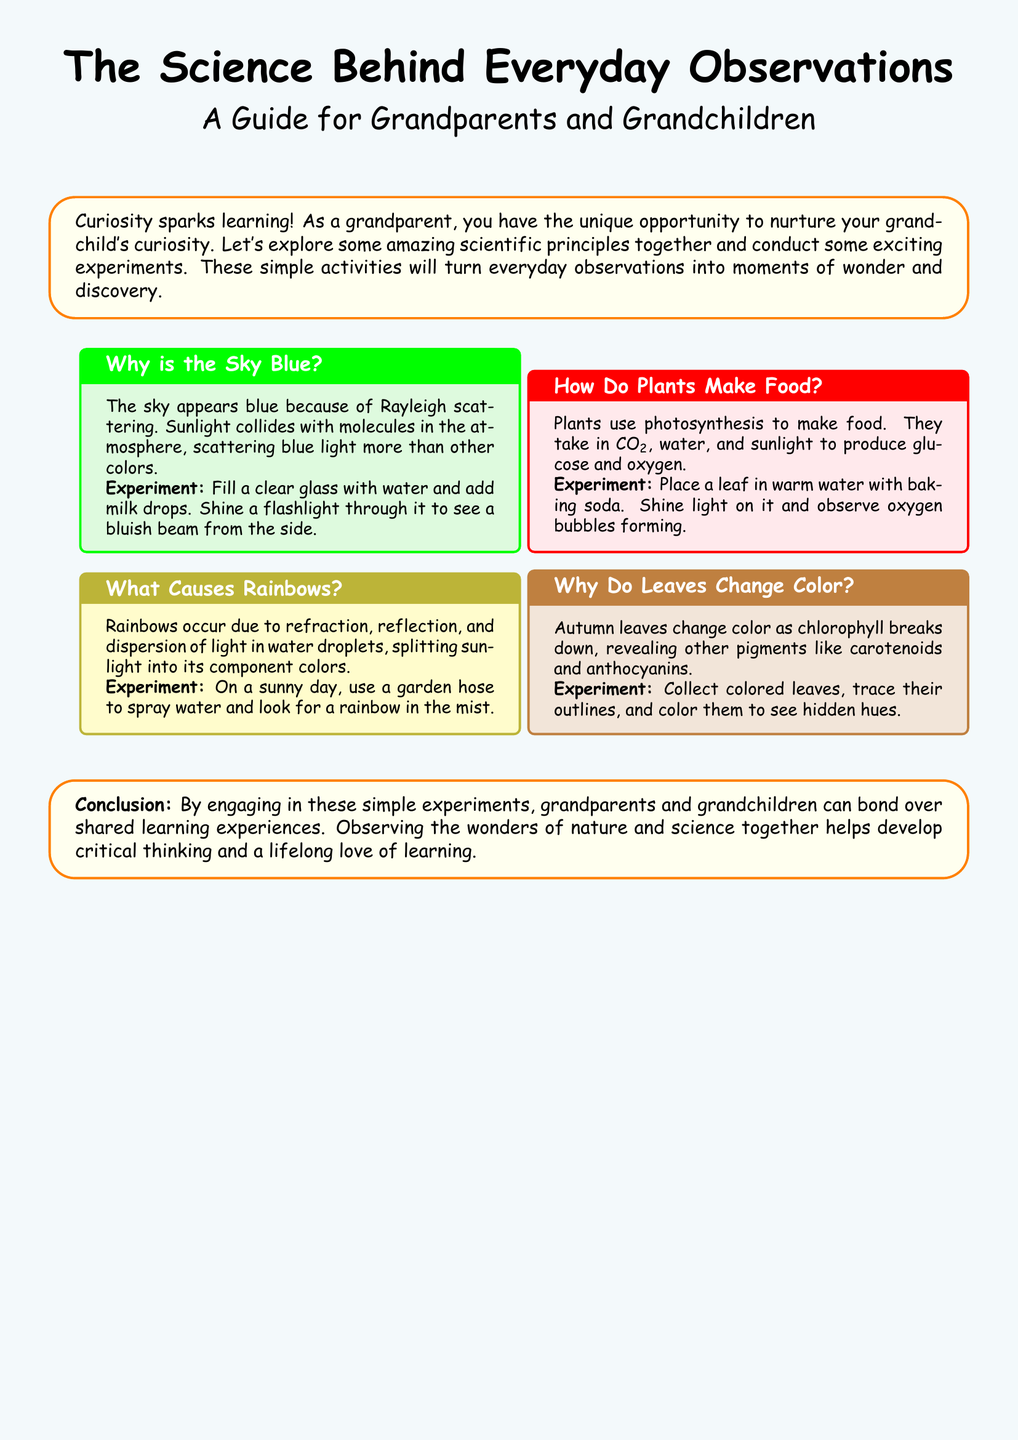What is the title of the flyer? The title is prominently displayed at the top of the flyer.
Answer: The Science Behind Everyday Observations Who is the intended audience for this guide? The document mentions the primary participants in the activities suggested.
Answer: Grandparents and Grandchildren What phenomenon explains why the sky is blue? The flyer provides a specific scientific term to describe the scattering process involved.
Answer: Rayleigh scattering What process do plants use to make food? The document specifies the scientific term for the process described.
Answer: Photosynthesis What experiment is suggested to observe oxygen bubbles? The flyer details a specific method involving a leaf and baking soda to visualize this phenomenon.
Answer: Place a leaf in warm water with baking soda What causes rainbows to occur? The flyer outlines the physical processes involved in the formation of rainbows.
Answer: Refraction, reflection, and dispersion of light What happens to chlorophyll in autumn leaves? The document explains the change that occurs in foliage during the fall season.
Answer: Breaks down What color are the boxes that contain the scientific principles? The document describes the color scheme used for the information boxes.
Answer: Light yellow, light green, light pink, yellow, brown What is the overarching goal of the document? The flyer concludes with a summary of what the activities aim to achieve along with their significance.
Answer: Bond over shared learning experiences 